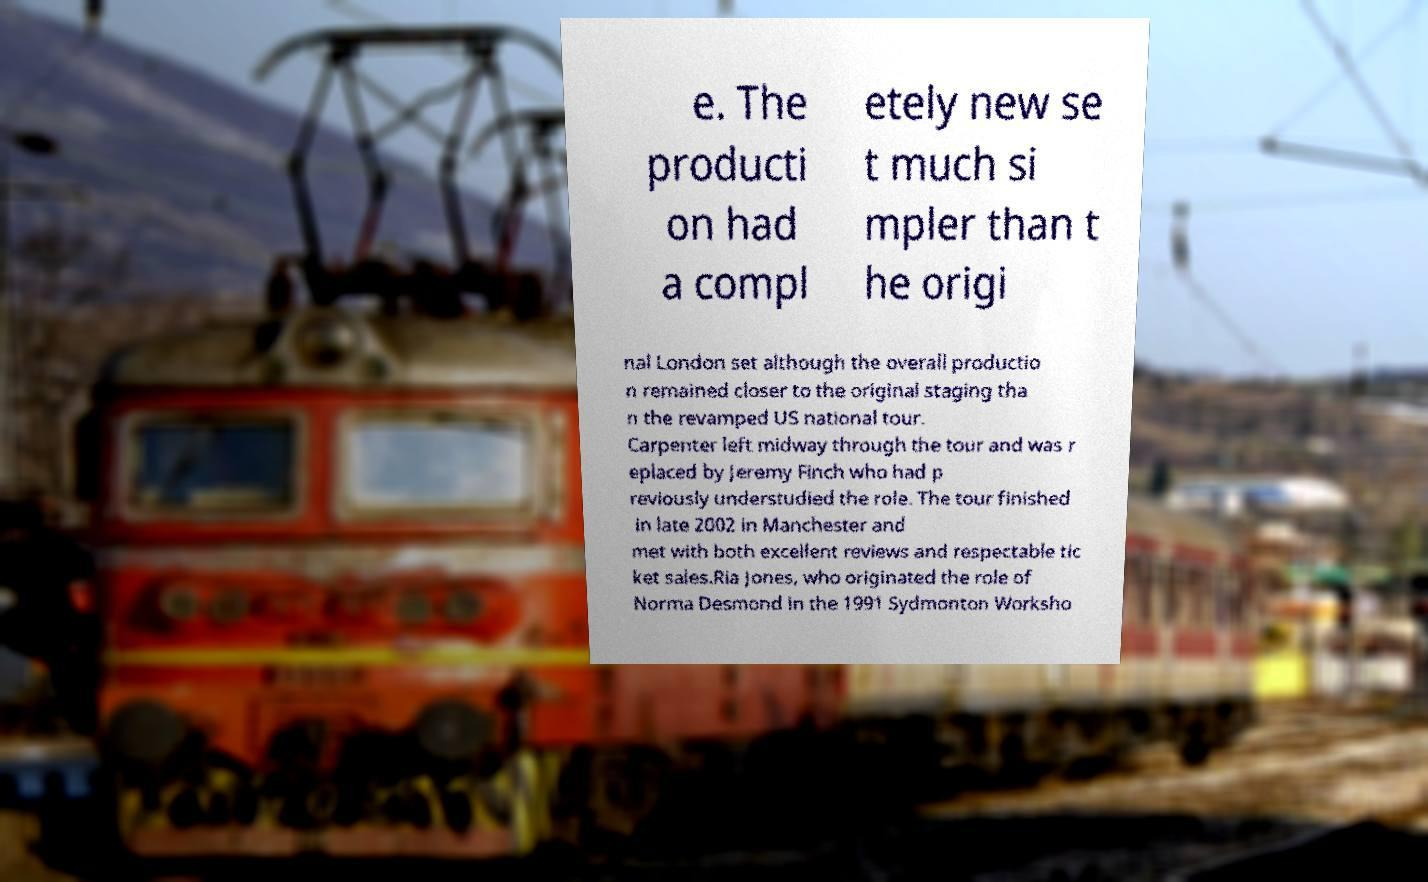Could you assist in decoding the text presented in this image and type it out clearly? e. The producti on had a compl etely new se t much si mpler than t he origi nal London set although the overall productio n remained closer to the original staging tha n the revamped US national tour. Carpenter left midway through the tour and was r eplaced by Jeremy Finch who had p reviously understudied the role. The tour finished in late 2002 in Manchester and met with both excellent reviews and respectable tic ket sales.Ria Jones, who originated the role of Norma Desmond in the 1991 Sydmonton Worksho 